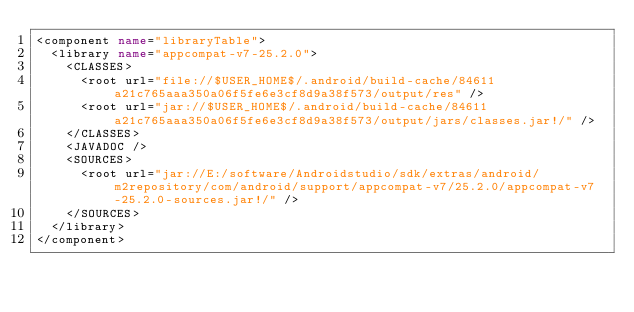<code> <loc_0><loc_0><loc_500><loc_500><_XML_><component name="libraryTable">
  <library name="appcompat-v7-25.2.0">
    <CLASSES>
      <root url="file://$USER_HOME$/.android/build-cache/84611a21c765aaa350a06f5fe6e3cf8d9a38f573/output/res" />
      <root url="jar://$USER_HOME$/.android/build-cache/84611a21c765aaa350a06f5fe6e3cf8d9a38f573/output/jars/classes.jar!/" />
    </CLASSES>
    <JAVADOC />
    <SOURCES>
      <root url="jar://E:/software/Androidstudio/sdk/extras/android/m2repository/com/android/support/appcompat-v7/25.2.0/appcompat-v7-25.2.0-sources.jar!/" />
    </SOURCES>
  </library>
</component></code> 